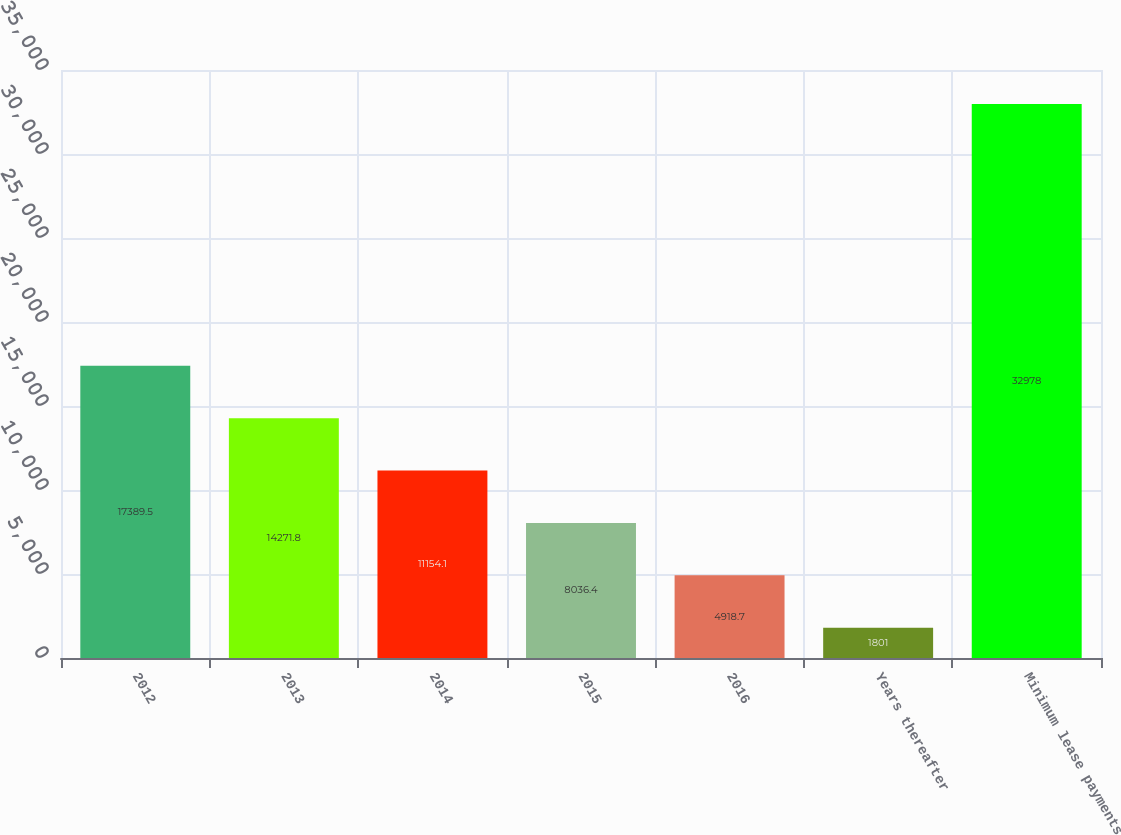Convert chart to OTSL. <chart><loc_0><loc_0><loc_500><loc_500><bar_chart><fcel>2012<fcel>2013<fcel>2014<fcel>2015<fcel>2016<fcel>Years thereafter<fcel>Minimum lease payments<nl><fcel>17389.5<fcel>14271.8<fcel>11154.1<fcel>8036.4<fcel>4918.7<fcel>1801<fcel>32978<nl></chart> 